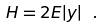<formula> <loc_0><loc_0><loc_500><loc_500>H = 2 E | y | \ .</formula> 